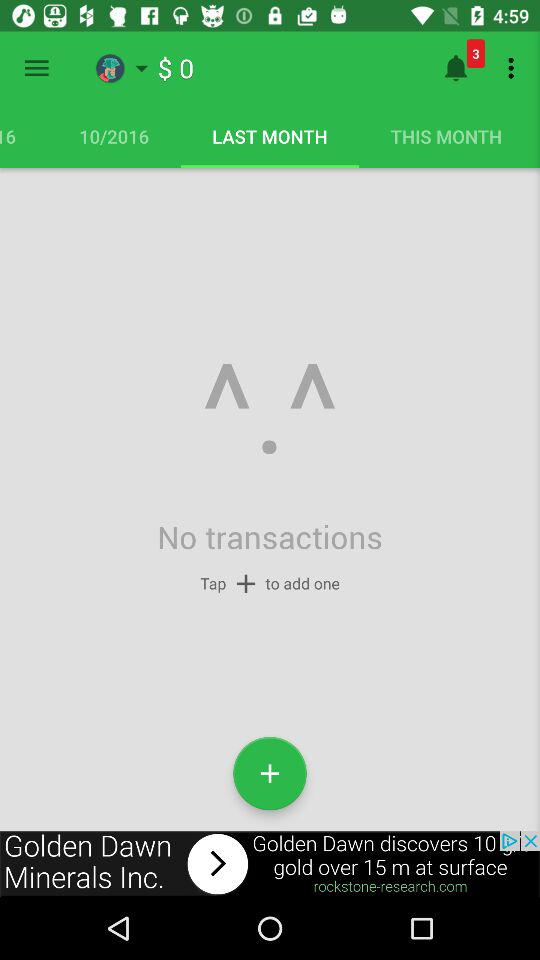How many more notifications do I have than transactions?
Answer the question using a single word or phrase. 3 